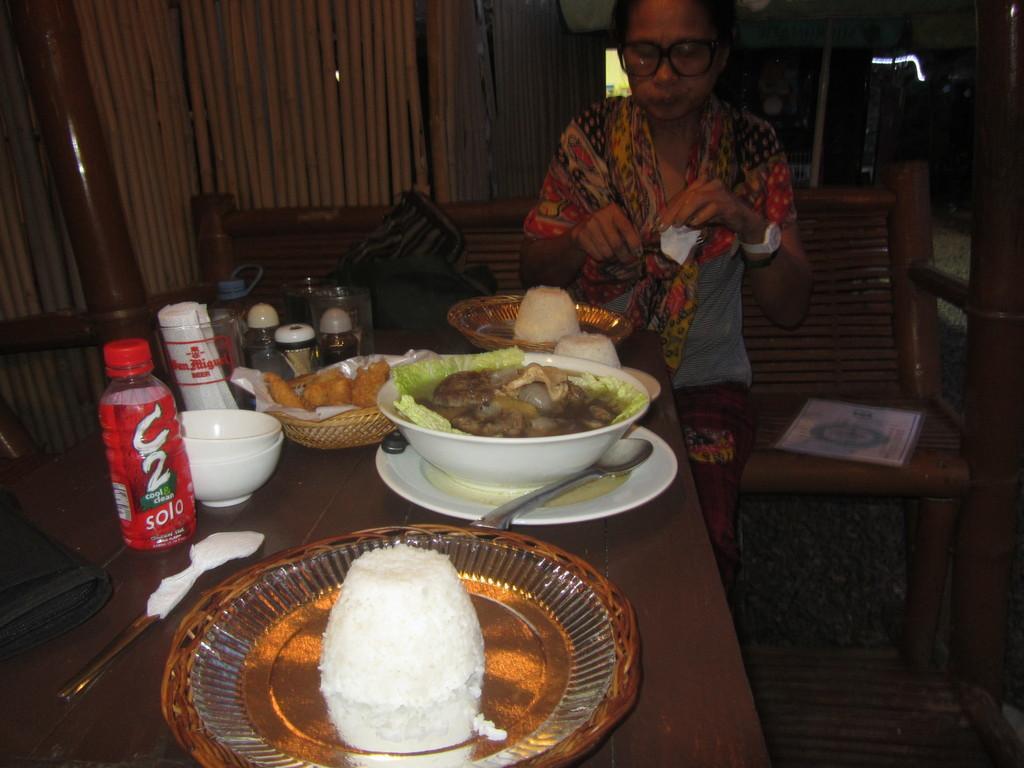How would you summarize this image in a sentence or two? There is a table in the foreground, on which there are bowls, plates, bottle, a bowl contains food items in it and other items on the table, there is a lady standing at the top side and there are bags on the bench, it seems like bamboo wall and other objects in the background area. 